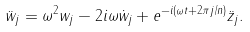<formula> <loc_0><loc_0><loc_500><loc_500>\ddot { w } _ { j } = \omega ^ { 2 } w _ { j } - 2 i \omega \dot { w } _ { j } + e ^ { - i ( \omega t + 2 \pi j / n ) } \ddot { z } _ { j } .</formula> 